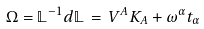Convert formula to latex. <formula><loc_0><loc_0><loc_500><loc_500>\Omega = \mathbb { L } ^ { - 1 } d \mathbb { L } \, = \, V ^ { A } K _ { A } + \omega ^ { \alpha } t _ { \alpha }</formula> 